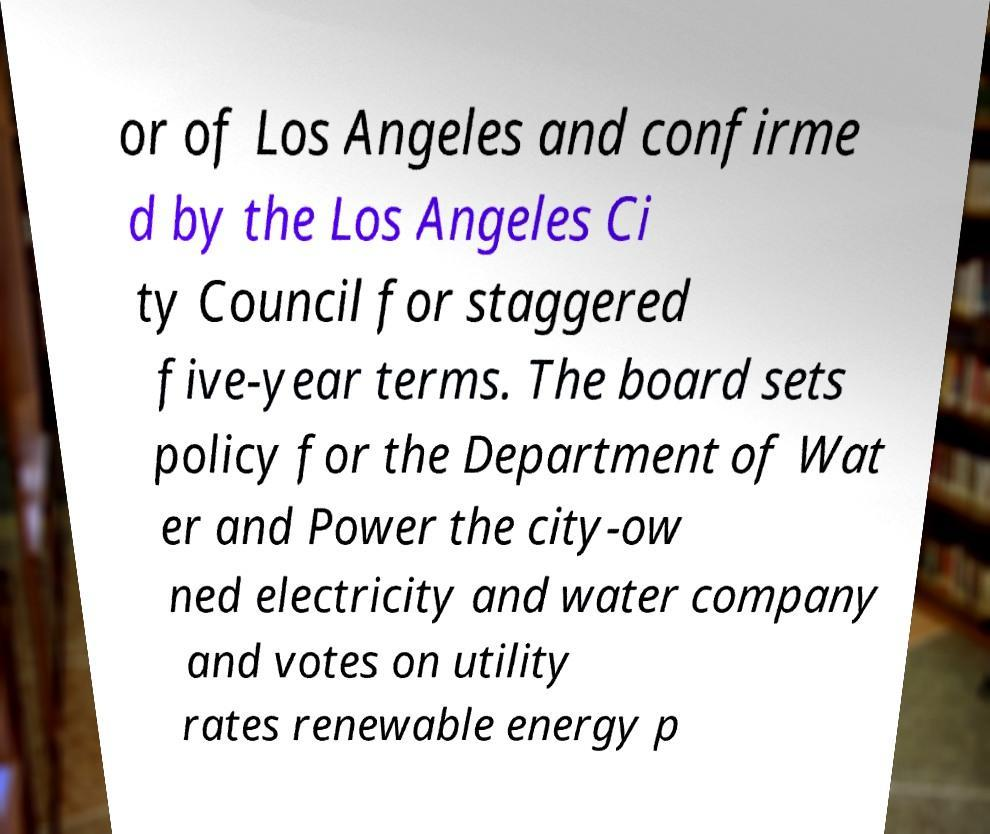Can you read and provide the text displayed in the image?This photo seems to have some interesting text. Can you extract and type it out for me? or of Los Angeles and confirme d by the Los Angeles Ci ty Council for staggered five-year terms. The board sets policy for the Department of Wat er and Power the city-ow ned electricity and water company and votes on utility rates renewable energy p 